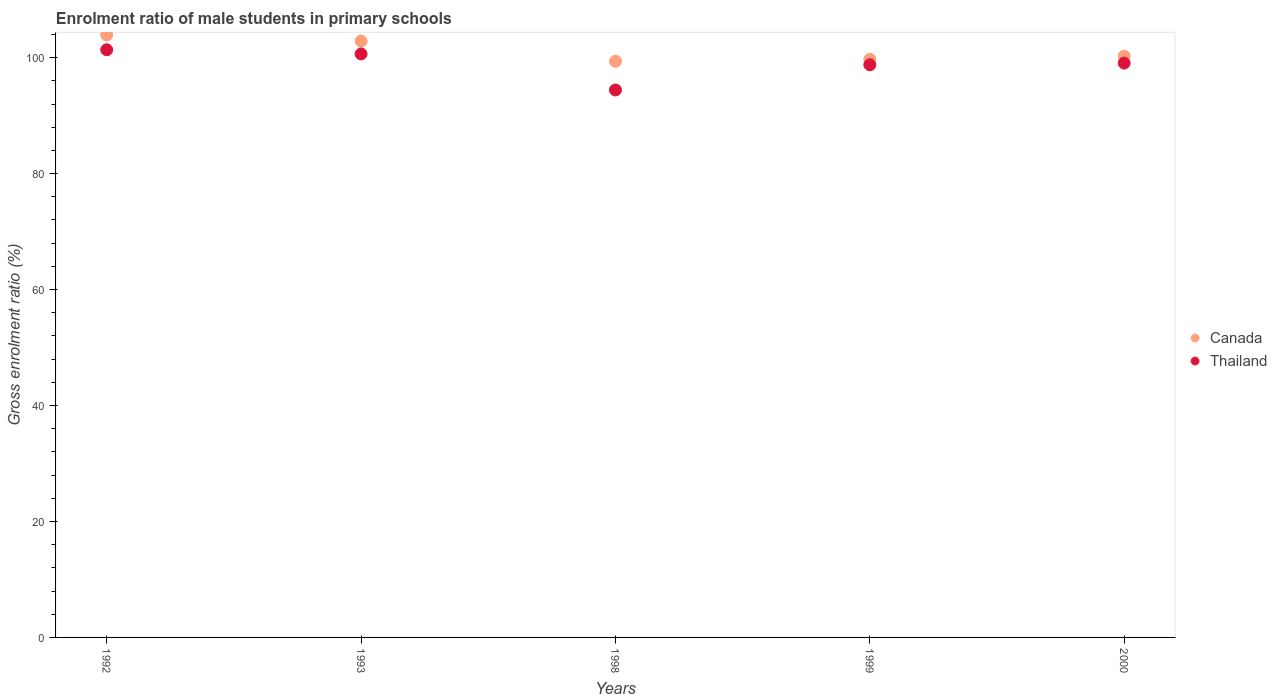How many different coloured dotlines are there?
Your answer should be compact. 2. What is the enrolment ratio of male students in primary schools in Thailand in 1992?
Make the answer very short. 101.36. Across all years, what is the maximum enrolment ratio of male students in primary schools in Canada?
Your response must be concise. 103.91. Across all years, what is the minimum enrolment ratio of male students in primary schools in Thailand?
Keep it short and to the point. 94.43. In which year was the enrolment ratio of male students in primary schools in Thailand maximum?
Keep it short and to the point. 1992. In which year was the enrolment ratio of male students in primary schools in Thailand minimum?
Your answer should be very brief. 1998. What is the total enrolment ratio of male students in primary schools in Canada in the graph?
Give a very brief answer. 506.12. What is the difference between the enrolment ratio of male students in primary schools in Thailand in 1999 and that in 2000?
Offer a very short reply. -0.29. What is the difference between the enrolment ratio of male students in primary schools in Thailand in 1993 and the enrolment ratio of male students in primary schools in Canada in 2000?
Your answer should be very brief. 0.38. What is the average enrolment ratio of male students in primary schools in Thailand per year?
Give a very brief answer. 98.85. In the year 1999, what is the difference between the enrolment ratio of male students in primary schools in Canada and enrolment ratio of male students in primary schools in Thailand?
Offer a very short reply. 0.94. What is the ratio of the enrolment ratio of male students in primary schools in Canada in 1998 to that in 1999?
Provide a short and direct response. 1. Is the difference between the enrolment ratio of male students in primary schools in Canada in 1992 and 1999 greater than the difference between the enrolment ratio of male students in primary schools in Thailand in 1992 and 1999?
Make the answer very short. Yes. What is the difference between the highest and the second highest enrolment ratio of male students in primary schools in Canada?
Ensure brevity in your answer.  1.04. What is the difference between the highest and the lowest enrolment ratio of male students in primary schools in Thailand?
Make the answer very short. 6.93. In how many years, is the enrolment ratio of male students in primary schools in Thailand greater than the average enrolment ratio of male students in primary schools in Thailand taken over all years?
Provide a short and direct response. 3. Is the sum of the enrolment ratio of male students in primary schools in Canada in 1993 and 2000 greater than the maximum enrolment ratio of male students in primary schools in Thailand across all years?
Give a very brief answer. Yes. Does the enrolment ratio of male students in primary schools in Canada monotonically increase over the years?
Provide a succinct answer. No. How many dotlines are there?
Ensure brevity in your answer.  2. What is the difference between two consecutive major ticks on the Y-axis?
Your response must be concise. 20. Are the values on the major ticks of Y-axis written in scientific E-notation?
Ensure brevity in your answer.  No. How are the legend labels stacked?
Your response must be concise. Vertical. What is the title of the graph?
Give a very brief answer. Enrolment ratio of male students in primary schools. Does "Grenada" appear as one of the legend labels in the graph?
Your answer should be very brief. No. What is the label or title of the Y-axis?
Offer a very short reply. Gross enrolment ratio (%). What is the Gross enrolment ratio (%) in Canada in 1992?
Your answer should be very brief. 103.91. What is the Gross enrolment ratio (%) of Thailand in 1992?
Ensure brevity in your answer.  101.36. What is the Gross enrolment ratio (%) of Canada in 1993?
Make the answer very short. 102.86. What is the Gross enrolment ratio (%) in Thailand in 1993?
Make the answer very short. 100.64. What is the Gross enrolment ratio (%) of Canada in 1998?
Provide a succinct answer. 99.37. What is the Gross enrolment ratio (%) in Thailand in 1998?
Provide a succinct answer. 94.43. What is the Gross enrolment ratio (%) in Canada in 1999?
Ensure brevity in your answer.  99.72. What is the Gross enrolment ratio (%) of Thailand in 1999?
Make the answer very short. 98.77. What is the Gross enrolment ratio (%) of Canada in 2000?
Your response must be concise. 100.26. What is the Gross enrolment ratio (%) of Thailand in 2000?
Offer a very short reply. 99.06. Across all years, what is the maximum Gross enrolment ratio (%) in Canada?
Your answer should be very brief. 103.91. Across all years, what is the maximum Gross enrolment ratio (%) in Thailand?
Your response must be concise. 101.36. Across all years, what is the minimum Gross enrolment ratio (%) of Canada?
Provide a succinct answer. 99.37. Across all years, what is the minimum Gross enrolment ratio (%) in Thailand?
Your answer should be very brief. 94.43. What is the total Gross enrolment ratio (%) in Canada in the graph?
Your answer should be compact. 506.12. What is the total Gross enrolment ratio (%) in Thailand in the graph?
Make the answer very short. 494.26. What is the difference between the Gross enrolment ratio (%) of Canada in 1992 and that in 1993?
Make the answer very short. 1.04. What is the difference between the Gross enrolment ratio (%) in Thailand in 1992 and that in 1993?
Provide a succinct answer. 0.72. What is the difference between the Gross enrolment ratio (%) in Canada in 1992 and that in 1998?
Ensure brevity in your answer.  4.53. What is the difference between the Gross enrolment ratio (%) of Thailand in 1992 and that in 1998?
Offer a very short reply. 6.93. What is the difference between the Gross enrolment ratio (%) in Canada in 1992 and that in 1999?
Make the answer very short. 4.19. What is the difference between the Gross enrolment ratio (%) in Thailand in 1992 and that in 1999?
Keep it short and to the point. 2.58. What is the difference between the Gross enrolment ratio (%) in Canada in 1992 and that in 2000?
Offer a very short reply. 3.65. What is the difference between the Gross enrolment ratio (%) in Thailand in 1992 and that in 2000?
Make the answer very short. 2.3. What is the difference between the Gross enrolment ratio (%) in Canada in 1993 and that in 1998?
Ensure brevity in your answer.  3.49. What is the difference between the Gross enrolment ratio (%) of Thailand in 1993 and that in 1998?
Keep it short and to the point. 6.21. What is the difference between the Gross enrolment ratio (%) in Canada in 1993 and that in 1999?
Your answer should be very brief. 3.15. What is the difference between the Gross enrolment ratio (%) in Thailand in 1993 and that in 1999?
Give a very brief answer. 1.87. What is the difference between the Gross enrolment ratio (%) in Canada in 1993 and that in 2000?
Make the answer very short. 2.6. What is the difference between the Gross enrolment ratio (%) of Thailand in 1993 and that in 2000?
Make the answer very short. 1.58. What is the difference between the Gross enrolment ratio (%) in Canada in 1998 and that in 1999?
Offer a very short reply. -0.34. What is the difference between the Gross enrolment ratio (%) in Thailand in 1998 and that in 1999?
Keep it short and to the point. -4.35. What is the difference between the Gross enrolment ratio (%) in Canada in 1998 and that in 2000?
Make the answer very short. -0.88. What is the difference between the Gross enrolment ratio (%) of Thailand in 1998 and that in 2000?
Ensure brevity in your answer.  -4.64. What is the difference between the Gross enrolment ratio (%) in Canada in 1999 and that in 2000?
Your answer should be very brief. -0.54. What is the difference between the Gross enrolment ratio (%) in Thailand in 1999 and that in 2000?
Your answer should be compact. -0.29. What is the difference between the Gross enrolment ratio (%) of Canada in 1992 and the Gross enrolment ratio (%) of Thailand in 1993?
Give a very brief answer. 3.27. What is the difference between the Gross enrolment ratio (%) of Canada in 1992 and the Gross enrolment ratio (%) of Thailand in 1998?
Your answer should be very brief. 9.48. What is the difference between the Gross enrolment ratio (%) in Canada in 1992 and the Gross enrolment ratio (%) in Thailand in 1999?
Make the answer very short. 5.13. What is the difference between the Gross enrolment ratio (%) in Canada in 1992 and the Gross enrolment ratio (%) in Thailand in 2000?
Provide a succinct answer. 4.84. What is the difference between the Gross enrolment ratio (%) in Canada in 1993 and the Gross enrolment ratio (%) in Thailand in 1998?
Ensure brevity in your answer.  8.44. What is the difference between the Gross enrolment ratio (%) of Canada in 1993 and the Gross enrolment ratio (%) of Thailand in 1999?
Ensure brevity in your answer.  4.09. What is the difference between the Gross enrolment ratio (%) in Canada in 1993 and the Gross enrolment ratio (%) in Thailand in 2000?
Provide a short and direct response. 3.8. What is the difference between the Gross enrolment ratio (%) of Canada in 1998 and the Gross enrolment ratio (%) of Thailand in 1999?
Your answer should be compact. 0.6. What is the difference between the Gross enrolment ratio (%) in Canada in 1998 and the Gross enrolment ratio (%) in Thailand in 2000?
Keep it short and to the point. 0.31. What is the difference between the Gross enrolment ratio (%) of Canada in 1999 and the Gross enrolment ratio (%) of Thailand in 2000?
Offer a very short reply. 0.66. What is the average Gross enrolment ratio (%) of Canada per year?
Your answer should be compact. 101.22. What is the average Gross enrolment ratio (%) of Thailand per year?
Your answer should be very brief. 98.85. In the year 1992, what is the difference between the Gross enrolment ratio (%) of Canada and Gross enrolment ratio (%) of Thailand?
Offer a terse response. 2.55. In the year 1993, what is the difference between the Gross enrolment ratio (%) in Canada and Gross enrolment ratio (%) in Thailand?
Ensure brevity in your answer.  2.22. In the year 1998, what is the difference between the Gross enrolment ratio (%) in Canada and Gross enrolment ratio (%) in Thailand?
Provide a succinct answer. 4.95. In the year 1999, what is the difference between the Gross enrolment ratio (%) of Canada and Gross enrolment ratio (%) of Thailand?
Offer a very short reply. 0.94. In the year 2000, what is the difference between the Gross enrolment ratio (%) in Canada and Gross enrolment ratio (%) in Thailand?
Provide a short and direct response. 1.2. What is the ratio of the Gross enrolment ratio (%) in Canada in 1992 to that in 1993?
Ensure brevity in your answer.  1.01. What is the ratio of the Gross enrolment ratio (%) in Thailand in 1992 to that in 1993?
Keep it short and to the point. 1.01. What is the ratio of the Gross enrolment ratio (%) in Canada in 1992 to that in 1998?
Provide a succinct answer. 1.05. What is the ratio of the Gross enrolment ratio (%) in Thailand in 1992 to that in 1998?
Offer a very short reply. 1.07. What is the ratio of the Gross enrolment ratio (%) of Canada in 1992 to that in 1999?
Your answer should be very brief. 1.04. What is the ratio of the Gross enrolment ratio (%) in Thailand in 1992 to that in 1999?
Give a very brief answer. 1.03. What is the ratio of the Gross enrolment ratio (%) of Canada in 1992 to that in 2000?
Your answer should be compact. 1.04. What is the ratio of the Gross enrolment ratio (%) in Thailand in 1992 to that in 2000?
Your answer should be very brief. 1.02. What is the ratio of the Gross enrolment ratio (%) in Canada in 1993 to that in 1998?
Your answer should be compact. 1.04. What is the ratio of the Gross enrolment ratio (%) in Thailand in 1993 to that in 1998?
Offer a very short reply. 1.07. What is the ratio of the Gross enrolment ratio (%) of Canada in 1993 to that in 1999?
Provide a short and direct response. 1.03. What is the ratio of the Gross enrolment ratio (%) in Thailand in 1993 to that in 1999?
Give a very brief answer. 1.02. What is the ratio of the Gross enrolment ratio (%) in Canada in 1993 to that in 2000?
Provide a succinct answer. 1.03. What is the ratio of the Gross enrolment ratio (%) in Thailand in 1993 to that in 2000?
Your answer should be very brief. 1.02. What is the ratio of the Gross enrolment ratio (%) of Canada in 1998 to that in 1999?
Offer a terse response. 1. What is the ratio of the Gross enrolment ratio (%) in Thailand in 1998 to that in 1999?
Make the answer very short. 0.96. What is the ratio of the Gross enrolment ratio (%) in Canada in 1998 to that in 2000?
Your response must be concise. 0.99. What is the ratio of the Gross enrolment ratio (%) in Thailand in 1998 to that in 2000?
Give a very brief answer. 0.95. What is the ratio of the Gross enrolment ratio (%) of Thailand in 1999 to that in 2000?
Provide a short and direct response. 1. What is the difference between the highest and the second highest Gross enrolment ratio (%) in Canada?
Offer a very short reply. 1.04. What is the difference between the highest and the second highest Gross enrolment ratio (%) of Thailand?
Provide a short and direct response. 0.72. What is the difference between the highest and the lowest Gross enrolment ratio (%) of Canada?
Offer a terse response. 4.53. What is the difference between the highest and the lowest Gross enrolment ratio (%) of Thailand?
Your answer should be very brief. 6.93. 